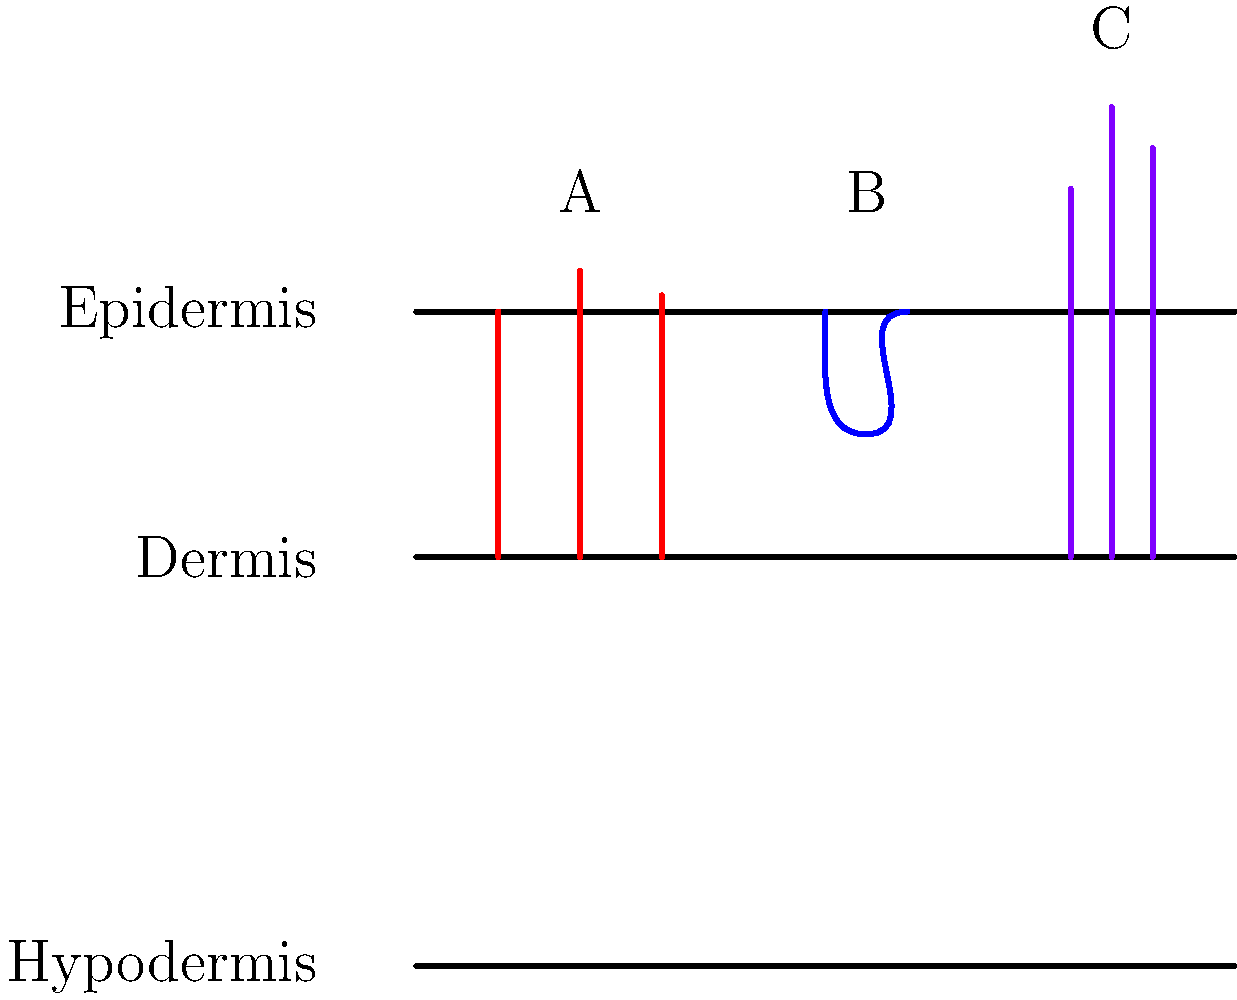Based on the cross-sectional skin graphic, identify the types of scars labeled A, B, and C. Which type of scar would likely require the most intensive management in terms of both physical treatment and emotional support for the patient? To answer this question, let's analyze each type of scar shown in the graphic:

1. Scar A: This shows raised tissue that remains within the boundaries of the original wound. This is characteristic of a hypertrophic scar.

2. Scar B: This depicts a depression in the skin, where the scar tissue is below the surrounding skin level. This represents an atrophic scar.

3. Scar C: This illustrates an overgrowth of scar tissue that extends beyond the original wound boundaries. This is typical of a keloid scar.

Now, let's consider which type would require the most intensive management:

1. Hypertrophic scars (A) can be bothersome but often improve over time and respond well to treatments like silicone sheets or steroid injections.

2. Atrophic scars (B) can be challenging to treat but are often less noticeable and may cause less emotional distress.

3. Keloid scars (C) tend to be the most problematic because:
   - They can continue to grow over time, becoming much larger than the original wound.
   - They can be itchy, painful, and restrict movement if near joints.
   - They are often more visible and can cause significant emotional distress.
   - They are notoriously difficult to treat, with a high recurrence rate even after surgical removal.
   - They may require a combination of treatments (e.g., surgery, radiation, pressure therapy, injections) over an extended period.
   - Patients with keloids may need ongoing emotional support due to the chronic nature of the condition and its impact on self-esteem and body image.

Therefore, keloid scars (C) would likely require the most intensive management in terms of both physical treatment and emotional support for the patient.
Answer: Keloid scars (C) 